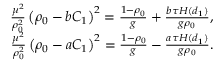<formula> <loc_0><loc_0><loc_500><loc_500>\begin{array} { r } { \frac { \mu ^ { 2 } } { \rho _ { 0 } ^ { 2 } } \left ( \rho _ { 0 } - b C _ { 1 } \right ) ^ { 2 } = \frac { 1 - \rho _ { 0 } } { g } + \frac { b \tau H ( d _ { 1 } ) } { g \rho _ { 0 } } , } \\ { \frac { \mu ^ { 2 } } { \rho _ { 0 } ^ { 2 } } \left ( \rho _ { 0 } - a C _ { 1 } \right ) ^ { 2 } = \frac { 1 - \rho _ { 0 } } { g } - \frac { a \tau H ( d _ { 1 } ) } { g \rho _ { 0 } } . } \end{array}</formula> 